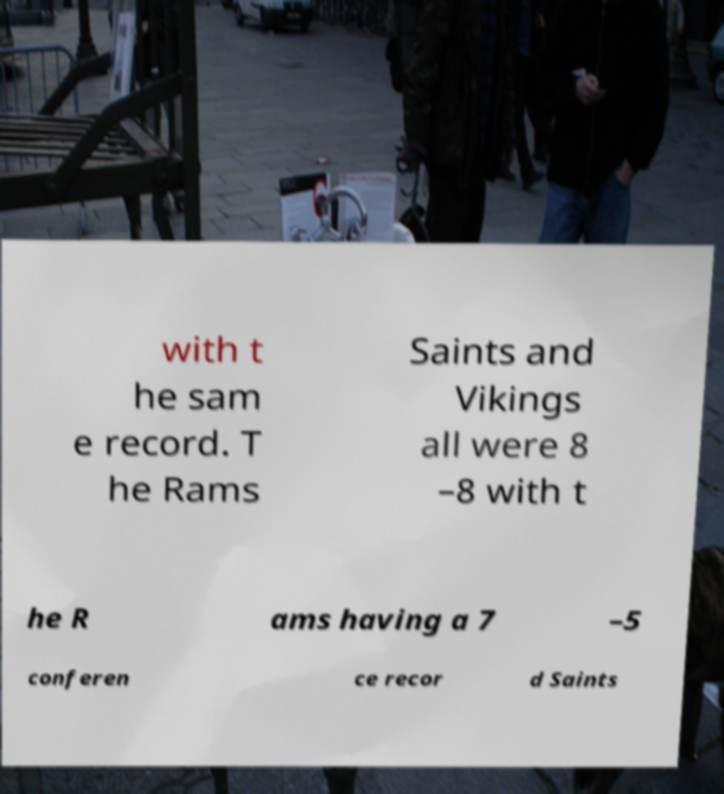Could you extract and type out the text from this image? with t he sam e record. T he Rams Saints and Vikings all were 8 –8 with t he R ams having a 7 –5 conferen ce recor d Saints 